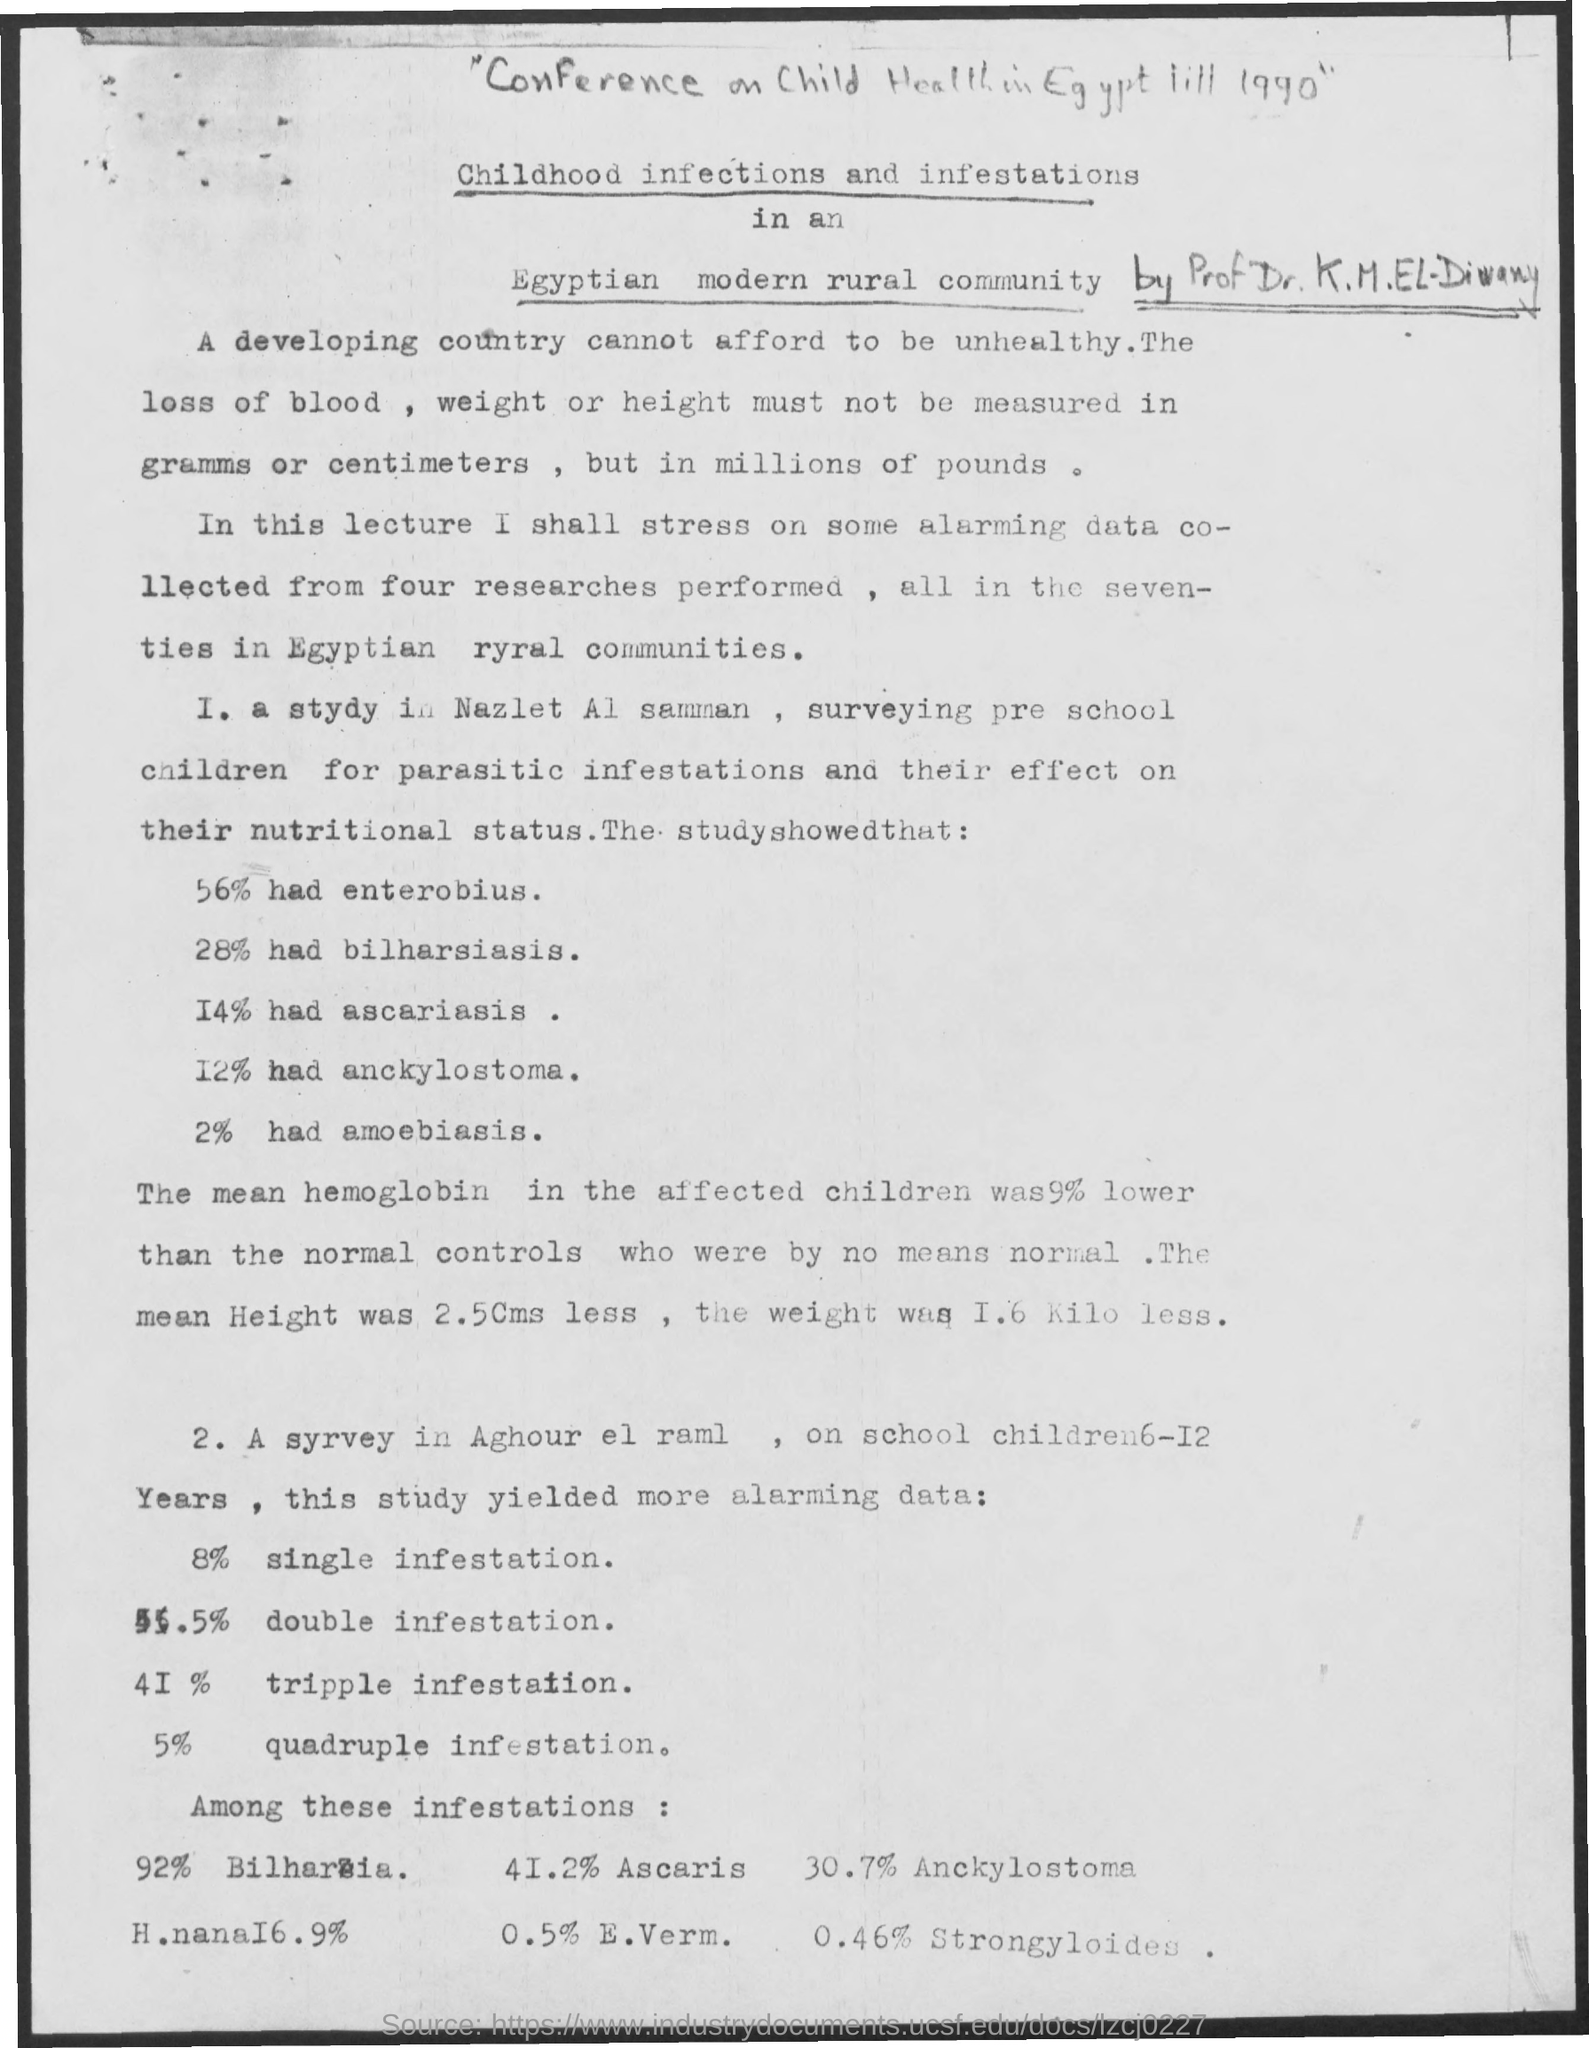What % had enterobius?
Make the answer very short. 56%. What % had bilharsiasis?
Offer a terse response. 28%. What % had ascariasis?
Offer a terse response. 14%. What % had anckylostoma?
Provide a succinct answer. 12%. What % had amoebiasis?
Keep it short and to the point. 2%. What % had single Infestation?
Ensure brevity in your answer.  8%. What % had Tripple Infestation?
Your response must be concise. 41%. What % had Quadruple Infestaion?
Your response must be concise. 5%. What % had Ascaris?
Offer a terse response. 41.2%. What % had E. Verm.?
Ensure brevity in your answer.  0.5%. 